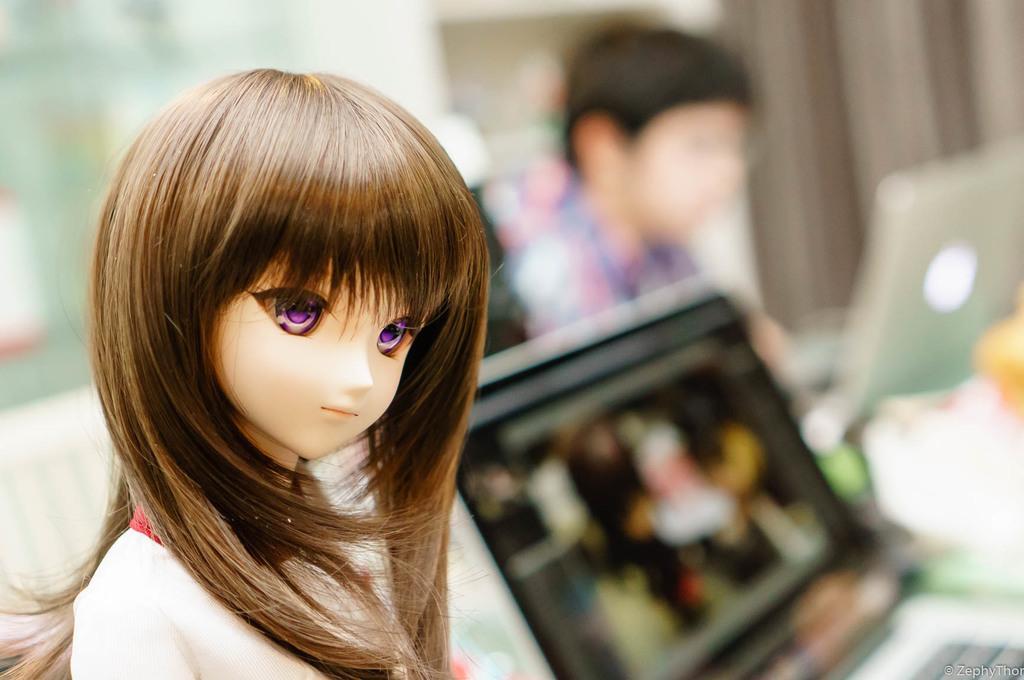In one or two sentences, can you explain what this image depicts? In this image we can see a doll, and in the background, we can see a person working on a laptop, beside him there is another laptop, and the background is blurred. 